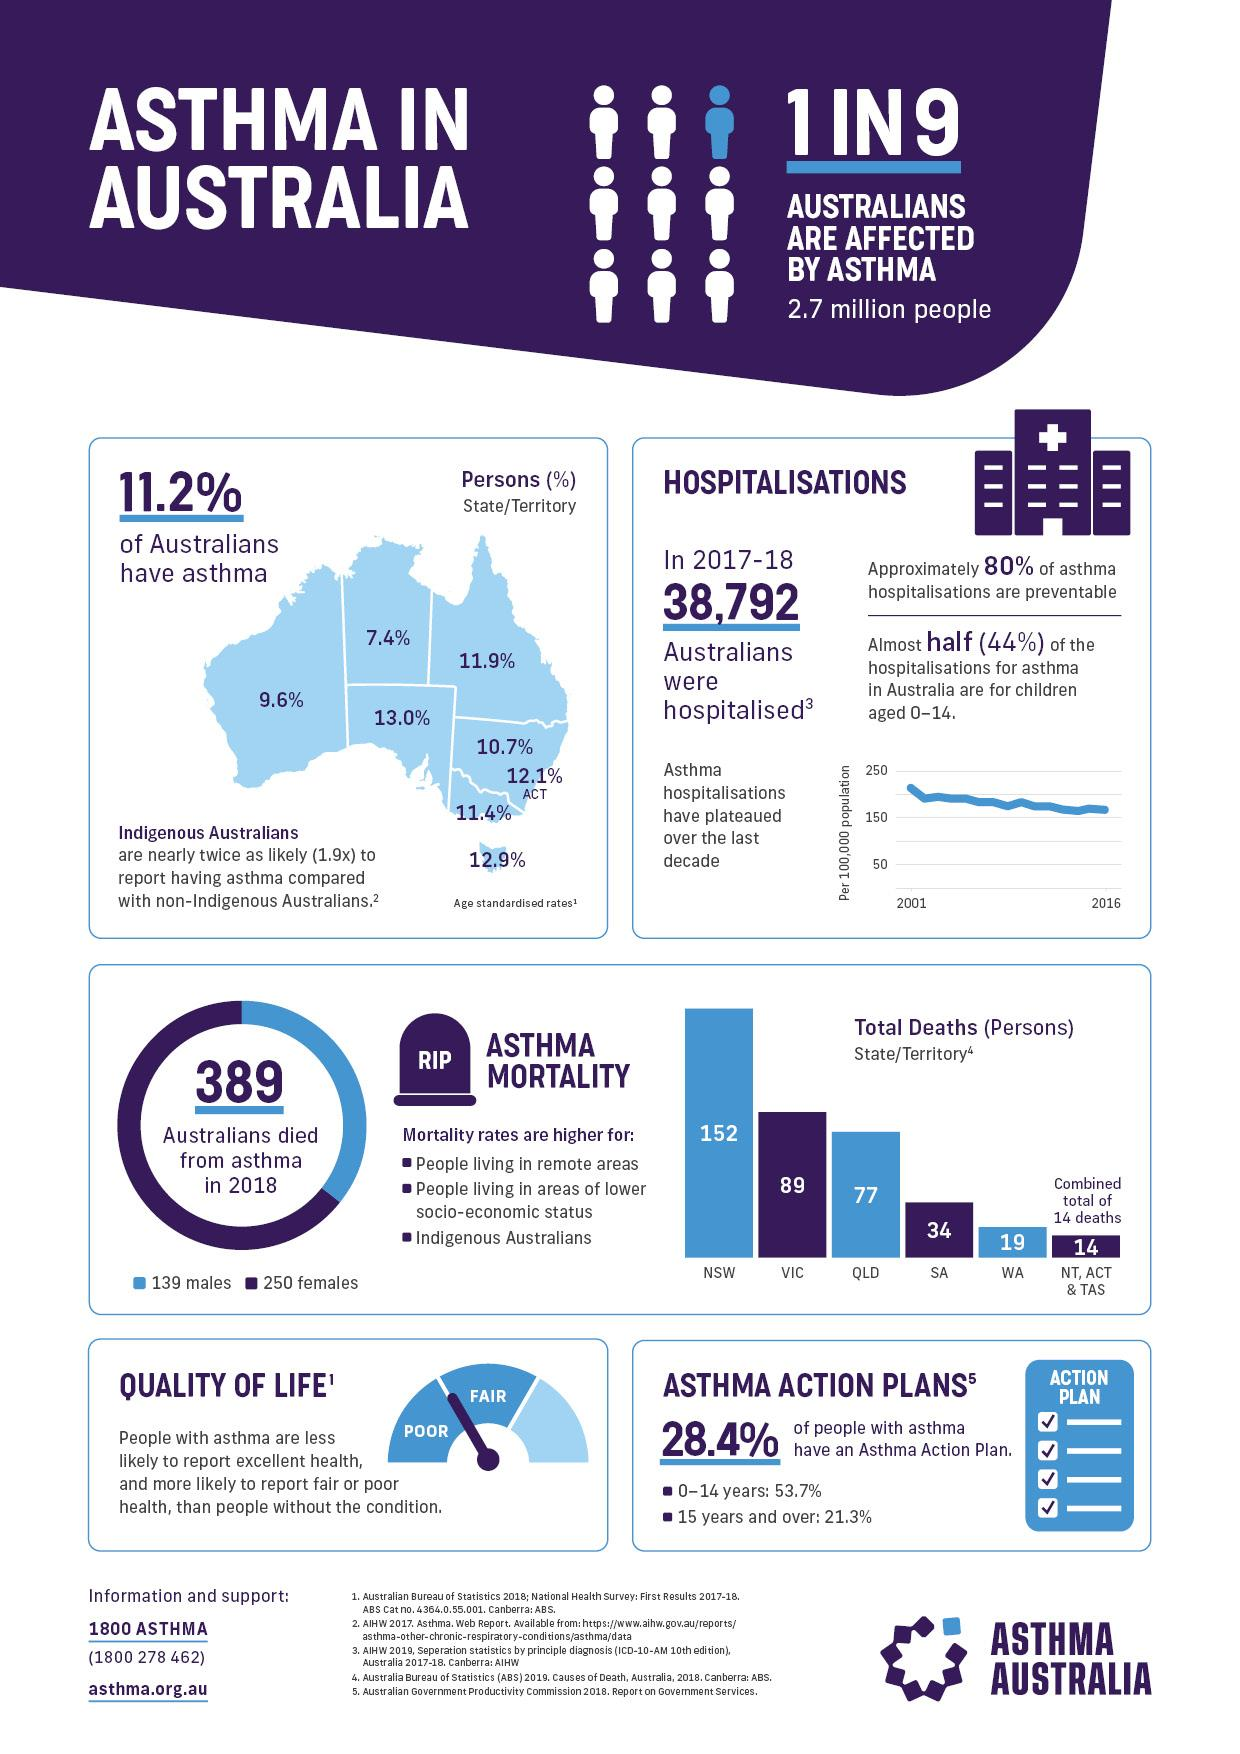Specify some key components in this picture. In Tasmania, 12.9% of the Australian population have asthma. What is written on the headstone? RIP is inscribed. The total number of deaths in Queensland is 77. In 2018, the number of female deaths was significantly higher than the number of male deaths. In Queensland and Victoria, approximately 23% of the population suffers from asthma. 